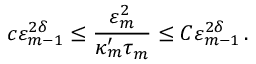<formula> <loc_0><loc_0><loc_500><loc_500>c \varepsilon _ { m - 1 } ^ { 2 \delta } \leq \frac { \varepsilon _ { m } ^ { 2 } } { \kappa _ { m } ^ { \prime } \tau _ { m } } \leq C \varepsilon _ { m - 1 } ^ { 2 \delta } \, .</formula> 